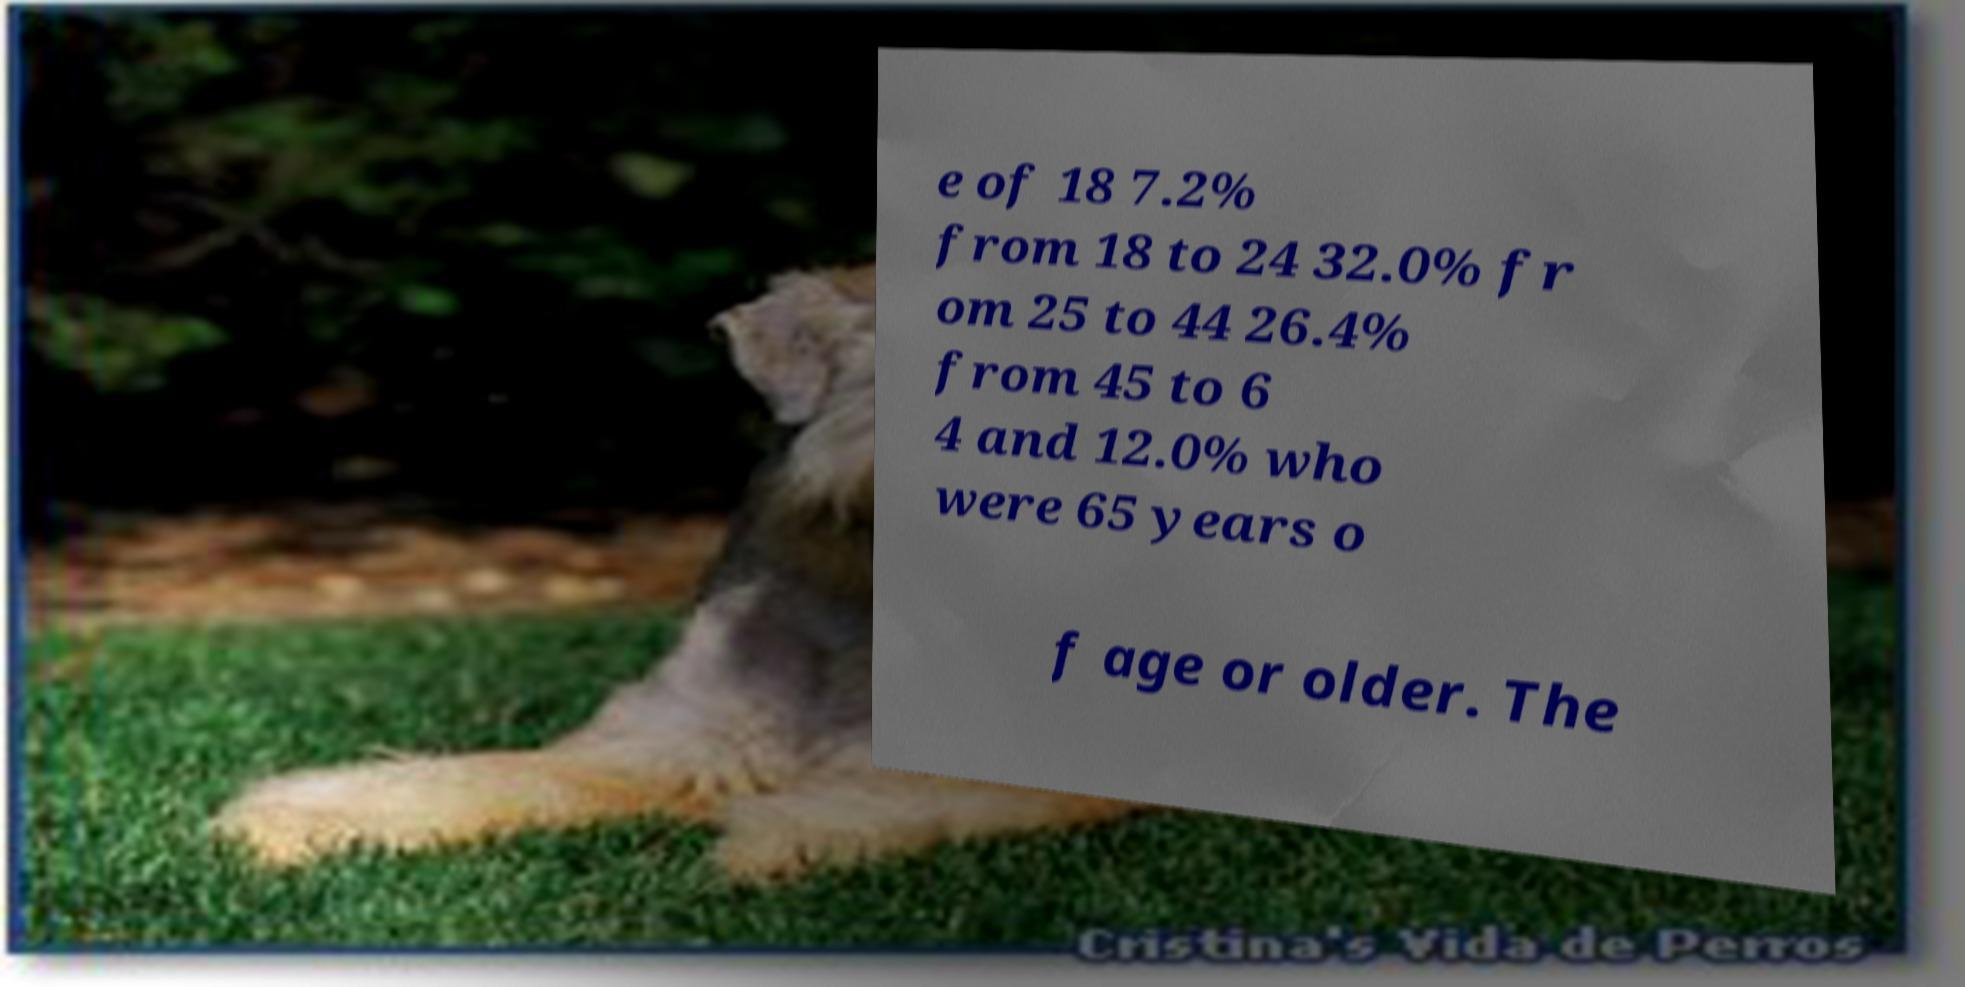Please read and relay the text visible in this image. What does it say? e of 18 7.2% from 18 to 24 32.0% fr om 25 to 44 26.4% from 45 to 6 4 and 12.0% who were 65 years o f age or older. The 